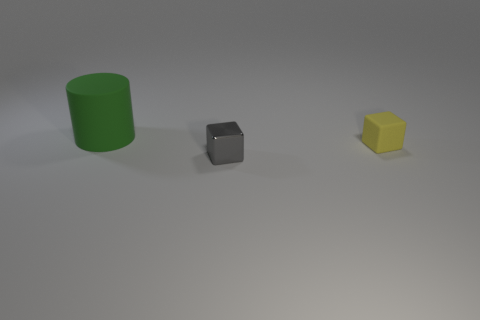Subtract 2 cubes. How many cubes are left? 0 Add 3 big purple matte blocks. How many objects exist? 6 Subtract all brown cylinders. Subtract all purple cubes. How many cylinders are left? 1 Subtract all brown cubes. How many blue cylinders are left? 0 Subtract all big things. Subtract all tiny blue metal cubes. How many objects are left? 2 Add 3 green rubber objects. How many green rubber objects are left? 4 Add 3 big brown metal cylinders. How many big brown metal cylinders exist? 3 Subtract 0 cyan cubes. How many objects are left? 3 Subtract all blocks. How many objects are left? 1 